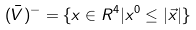Convert formula to latex. <formula><loc_0><loc_0><loc_500><loc_500>( \bar { V } ) ^ { - } = \{ x \in { R ^ { 4 } } | x ^ { 0 } \leq | \vec { x } | \}</formula> 